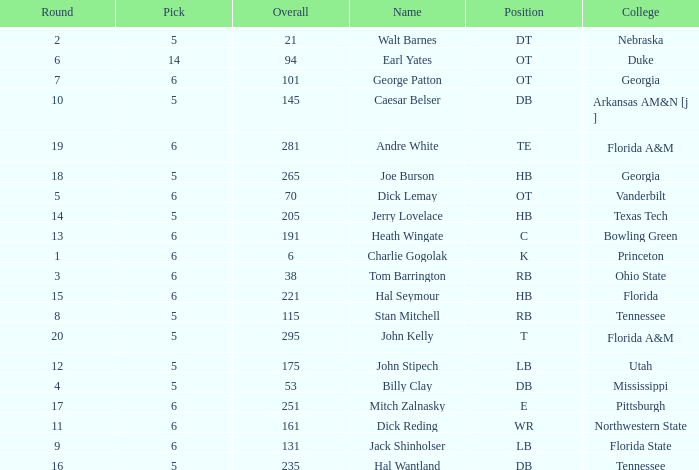What is Name, when Overall is less than 175, and when College is "Georgia"? George Patton. 